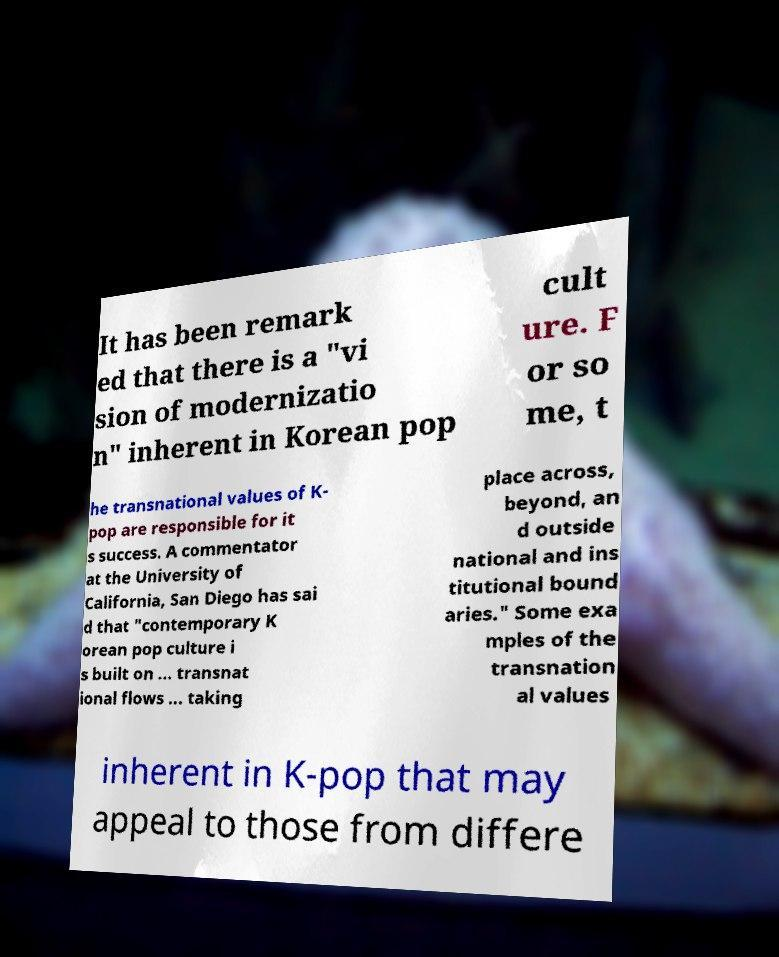Please read and relay the text visible in this image. What does it say? It has been remark ed that there is a "vi sion of modernizatio n" inherent in Korean pop cult ure. F or so me, t he transnational values of K- pop are responsible for it s success. A commentator at the University of California, San Diego has sai d that "contemporary K orean pop culture i s built on ... transnat ional flows ... taking place across, beyond, an d outside national and ins titutional bound aries." Some exa mples of the transnation al values inherent in K-pop that may appeal to those from differe 